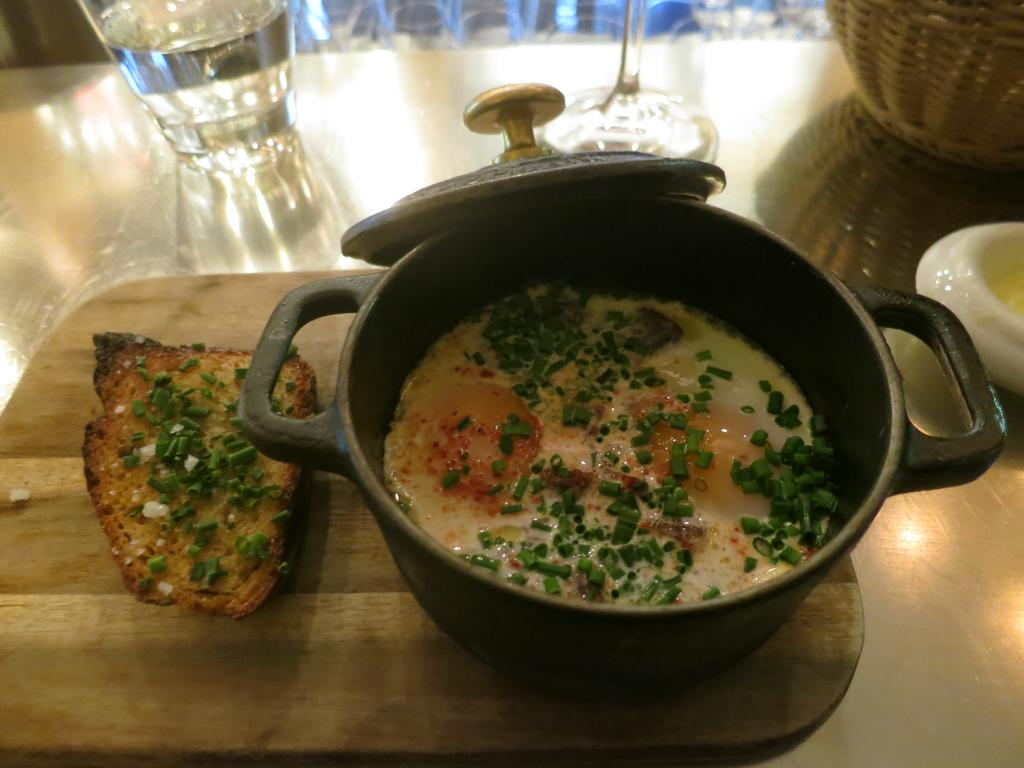What is in the bowl that is visible in the image? There is a bowl with a food item in the image. What is the wooden surface used for in the image? There are food items and glasses on the wooden surface, suggesting it is a table or countertop. What type of container is present in the image? There is a basket in the image. What other items can be seen on the wooden surface? There are additional items on the wooden surface, but their specific nature is not mentioned in the facts. Can you see any fangs on the food items in the image? There are no fangs present on the food items in the image. 